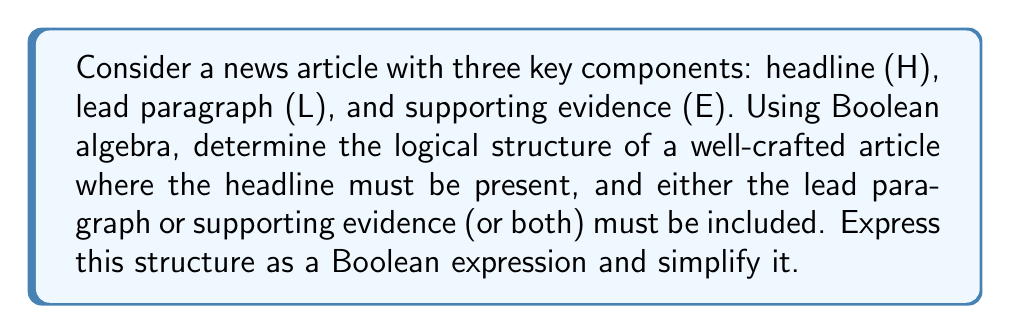Show me your answer to this math problem. Let's approach this step-by-step:

1) First, we need to express the conditions in Boolean terms:
   - The headline (H) must be present: This is represented by H
   - Either the lead paragraph (L) or supporting evidence (E) or both must be included: This is represented by (L + E)

2) The overall structure can be expressed as the AND of these two conditions:
   $$ H \cdot (L + E) $$

3) To simplify this expression, we can use the distributive property of Boolean algebra:
   $$ H \cdot (L + E) = (H \cdot L) + (H \cdot E) $$

4) This simplified form represents:
   - (H · L): Articles with headline and lead paragraph
   - (H · E): Articles with headline and supporting evidence

5) The '+' (OR) operation between these terms means that a well-crafted article could have either or both of these combinations.

6) This expression cannot be simplified further as it's already in its most reduced form.

For a novelist with a journalism background, this Boolean structure reflects the essential components of news writing: a compelling headline (H) is always necessary, accompanied by either a strong lead (L) to hook the reader or solid evidence (E) to support the story, or ideally both.
Answer: $$ H \cdot (L + E) = (H \cdot L) + (H \cdot E) $$ 